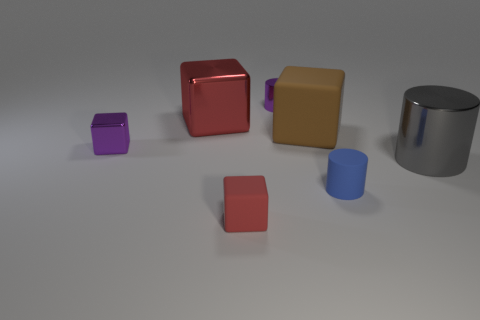Subtract all tiny cylinders. How many cylinders are left? 1 Add 3 tiny green shiny cubes. How many objects exist? 10 Subtract all blue cylinders. How many red blocks are left? 2 Subtract all brown cubes. How many cubes are left? 3 Subtract 2 cylinders. How many cylinders are left? 1 Subtract all blue blocks. Subtract all brown cylinders. How many blocks are left? 4 Subtract all large red shiny blocks. Subtract all small purple metallic cylinders. How many objects are left? 5 Add 4 big gray shiny things. How many big gray shiny things are left? 5 Add 3 small red objects. How many small red objects exist? 4 Subtract 0 blue spheres. How many objects are left? 7 